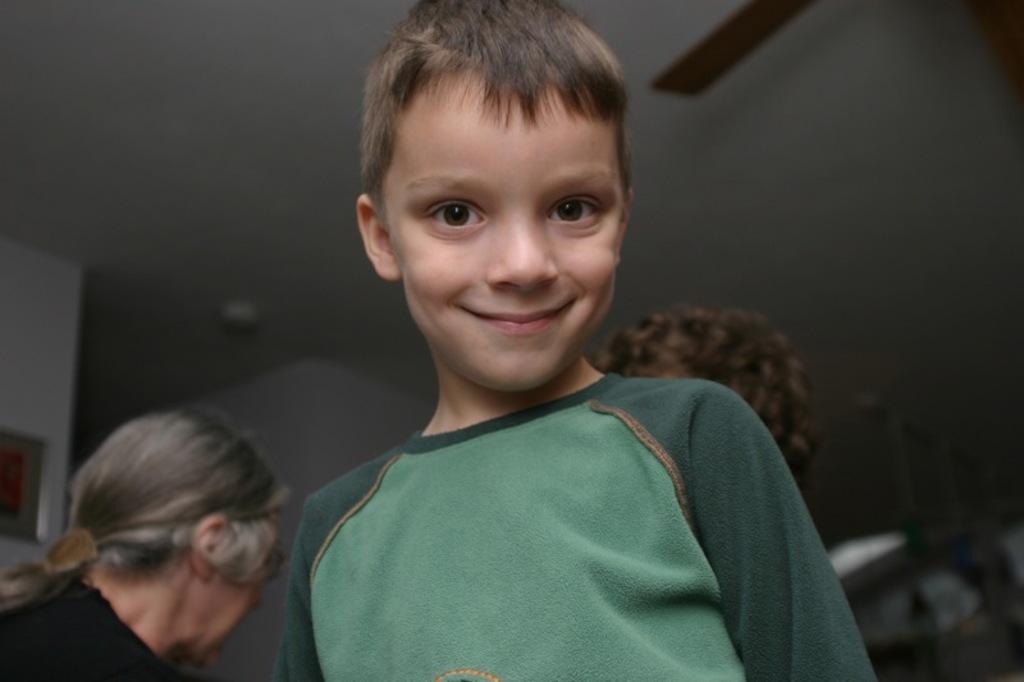In one or two sentences, can you explain what this image depicts? In this picture I can see a boy is wearing the t-shirt, on the left side there is a woman, in the background I can see the walls and a roof. On the right side I can see the human hair. 